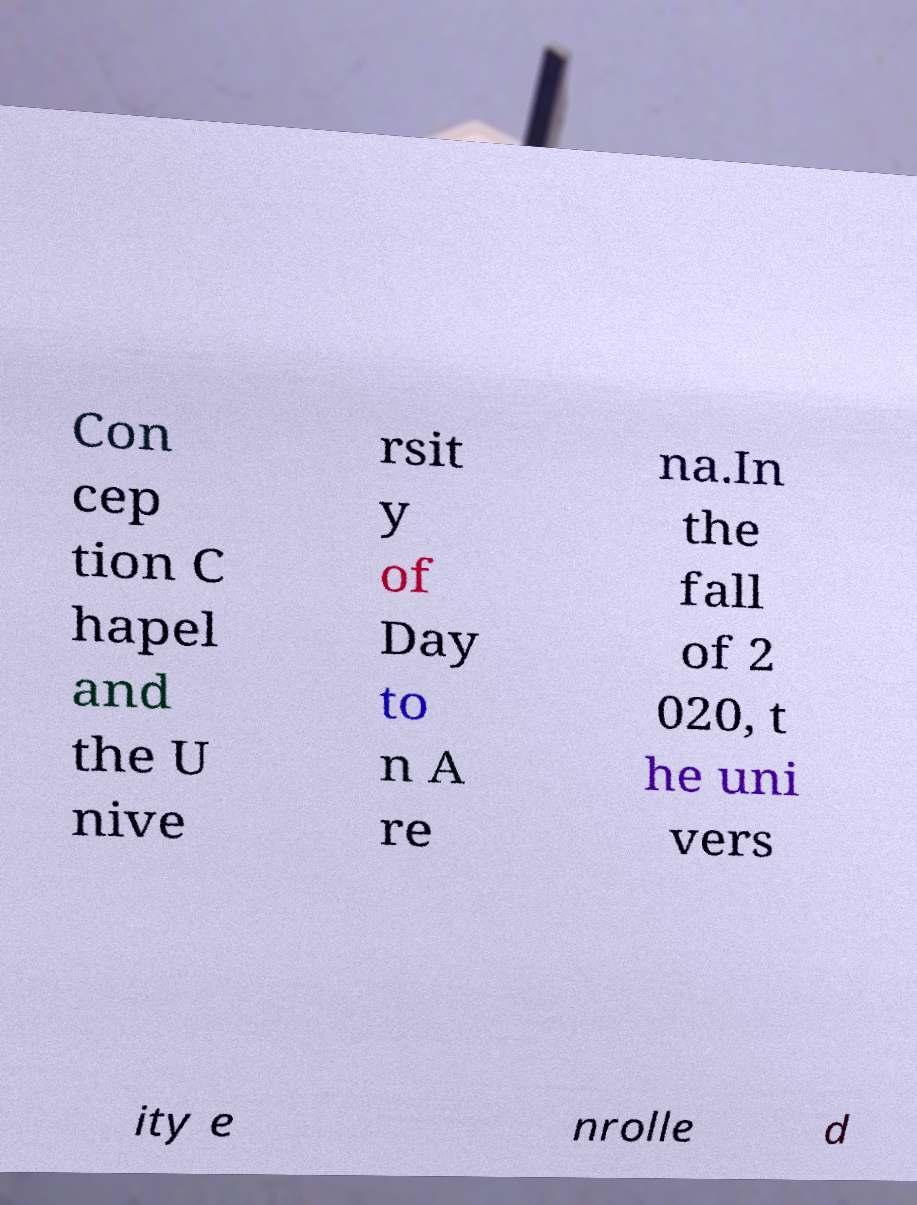Can you accurately transcribe the text from the provided image for me? Con cep tion C hapel and the U nive rsit y of Day to n A re na.In the fall of 2 020, t he uni vers ity e nrolle d 